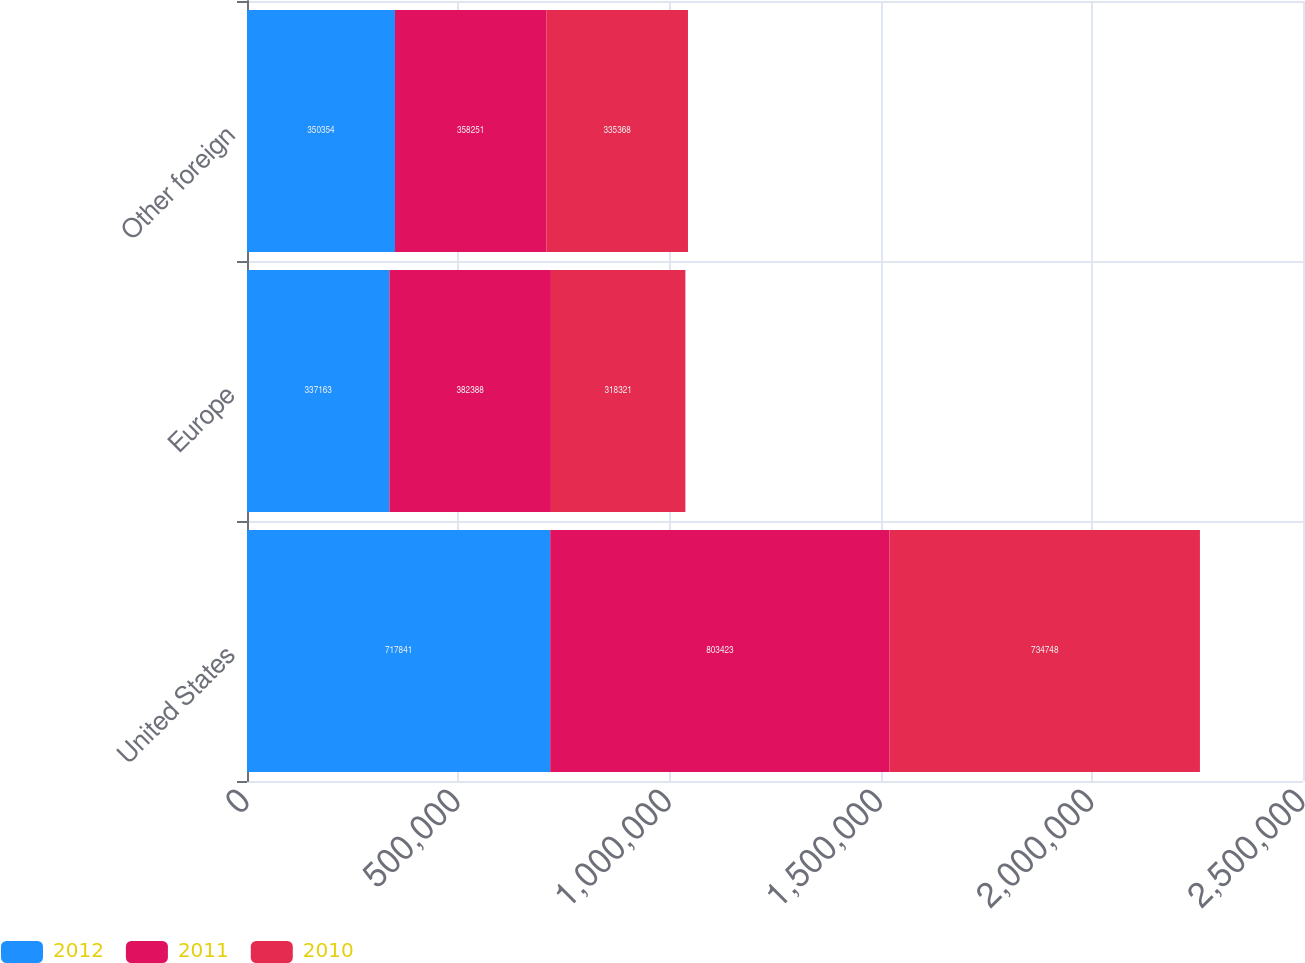<chart> <loc_0><loc_0><loc_500><loc_500><stacked_bar_chart><ecel><fcel>United States<fcel>Europe<fcel>Other foreign<nl><fcel>2012<fcel>717841<fcel>337163<fcel>350354<nl><fcel>2011<fcel>803423<fcel>382388<fcel>358251<nl><fcel>2010<fcel>734748<fcel>318321<fcel>335368<nl></chart> 